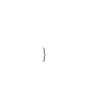<code> <loc_0><loc_0><loc_500><loc_500><_Java_>}
</code> 